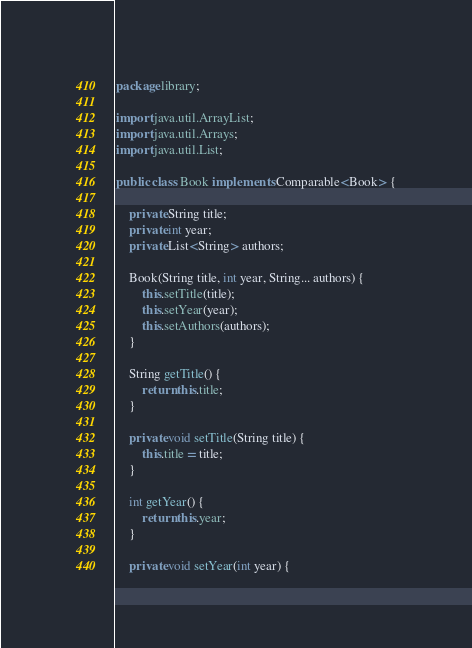Convert code to text. <code><loc_0><loc_0><loc_500><loc_500><_Java_>package library;

import java.util.ArrayList;
import java.util.Arrays;
import java.util.List;

public class Book implements Comparable<Book> {

    private String title;
    private int year;
    private List<String> authors;

    Book(String title, int year, String... authors) {
        this.setTitle(title);
        this.setYear(year);
        this.setAuthors(authors);
    }

    String getTitle() {
        return this.title;
    }

    private void setTitle(String title) {
        this.title = title;
    }

    int getYear() {
        return this.year;
    }

    private void setYear(int year) {</code> 